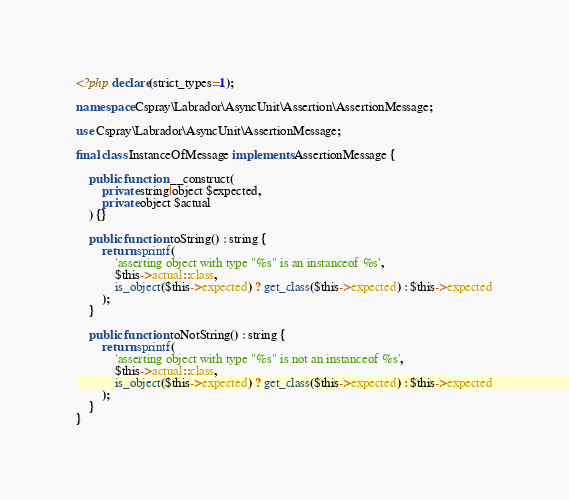Convert code to text. <code><loc_0><loc_0><loc_500><loc_500><_PHP_><?php declare(strict_types=1);

namespace Cspray\Labrador\AsyncUnit\Assertion\AssertionMessage;

use Cspray\Labrador\AsyncUnit\AssertionMessage;

final class InstanceOfMessage implements AssertionMessage {

    public function __construct(
        private string|object $expected,
        private object $actual
    ) {}

    public function toString() : string {
        return sprintf(
            'asserting object with type "%s" is an instanceof %s',
            $this->actual::class,
            is_object($this->expected) ? get_class($this->expected) : $this->expected
        );
    }

    public function toNotString() : string {
        return sprintf(
            'asserting object with type "%s" is not an instanceof %s',
            $this->actual::class,
            is_object($this->expected) ? get_class($this->expected) : $this->expected
        );
    }
}</code> 